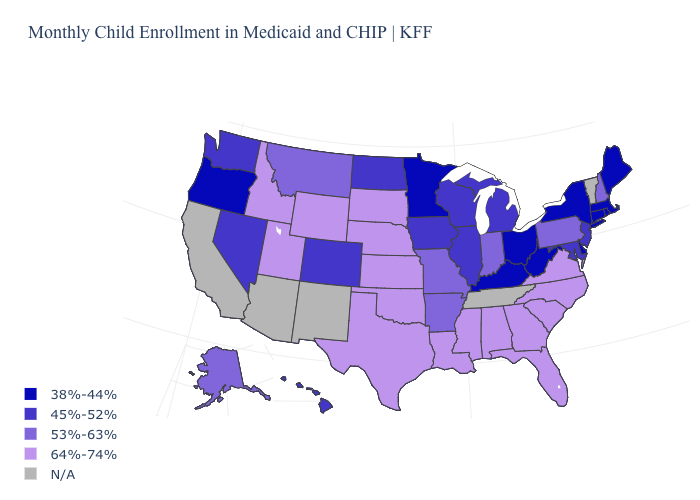Name the states that have a value in the range N/A?
Write a very short answer. Arizona, California, New Mexico, Tennessee, Vermont. What is the value of California?
Be succinct. N/A. What is the value of Alabama?
Keep it brief. 64%-74%. What is the value of South Dakota?
Keep it brief. 64%-74%. Name the states that have a value in the range 64%-74%?
Answer briefly. Alabama, Florida, Georgia, Idaho, Kansas, Louisiana, Mississippi, Nebraska, North Carolina, Oklahoma, South Carolina, South Dakota, Texas, Utah, Virginia, Wyoming. Among the states that border Washington , does Idaho have the highest value?
Quick response, please. Yes. Name the states that have a value in the range 38%-44%?
Give a very brief answer. Connecticut, Delaware, Kentucky, Maine, Massachusetts, Minnesota, New York, Ohio, Oregon, Rhode Island, West Virginia. What is the value of West Virginia?
Answer briefly. 38%-44%. What is the value of West Virginia?
Quick response, please. 38%-44%. Among the states that border Arizona , which have the lowest value?
Answer briefly. Colorado, Nevada. What is the lowest value in the USA?
Quick response, please. 38%-44%. Name the states that have a value in the range 38%-44%?
Short answer required. Connecticut, Delaware, Kentucky, Maine, Massachusetts, Minnesota, New York, Ohio, Oregon, Rhode Island, West Virginia. What is the value of New Jersey?
Short answer required. 45%-52%. Name the states that have a value in the range 64%-74%?
Write a very short answer. Alabama, Florida, Georgia, Idaho, Kansas, Louisiana, Mississippi, Nebraska, North Carolina, Oklahoma, South Carolina, South Dakota, Texas, Utah, Virginia, Wyoming. 